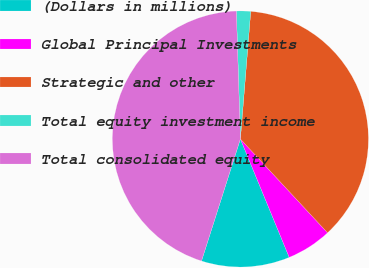Convert chart to OTSL. <chart><loc_0><loc_0><loc_500><loc_500><pie_chart><fcel>(Dollars in millions)<fcel>Global Principal Investments<fcel>Strategic and other<fcel>Total equity investment income<fcel>Total consolidated equity<nl><fcel>11.14%<fcel>5.69%<fcel>36.8%<fcel>1.79%<fcel>44.59%<nl></chart> 